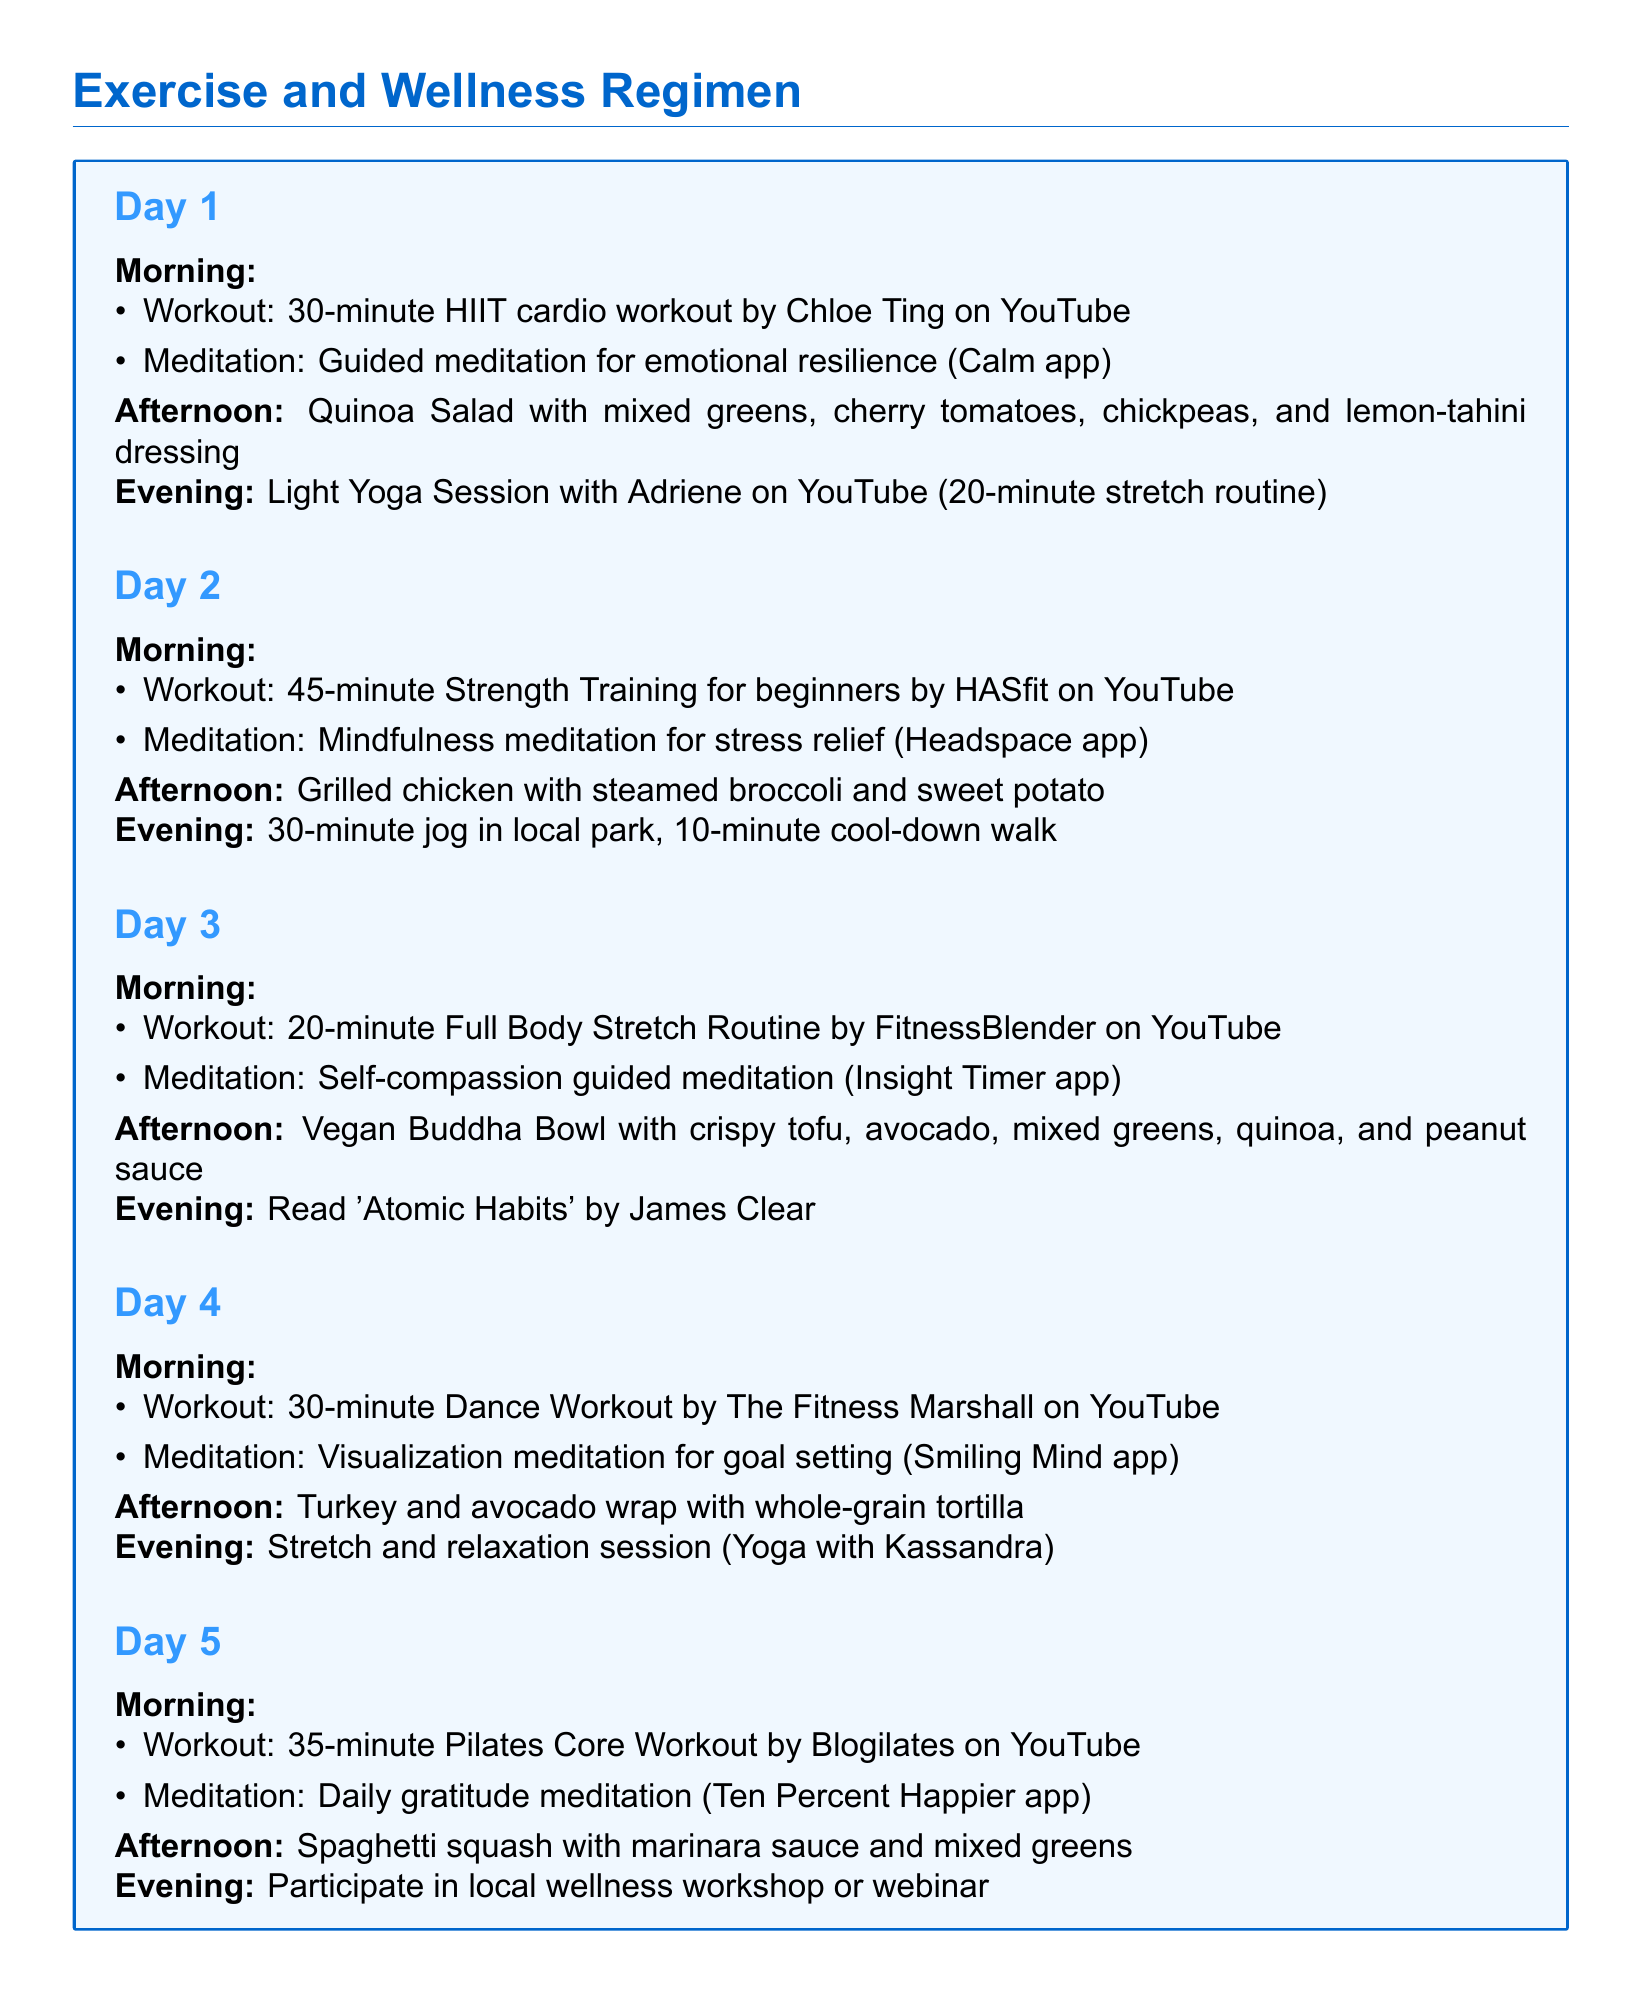what is the duration of the HIIT cardio workout? The HIIT cardio workout including details in the document specifies a duration of 30 minutes.
Answer: 30 minutes which app is used for emotional resilience meditation? The document lists the Calm app for the guided meditation focused on emotional resilience.
Answer: Calm app how many days are included in the exercise regimen? The document outlines a total of five days for the exercise and wellness regimen.
Answer: Five days what is the lunch option on Day 3? The lunch option provided for Day 3 in the document is a Vegan Buddha Bowl.
Answer: Vegan Buddha Bowl what type of workout is scheduled for the morning of Day 4? In the morning of Day 4, the document schedules a 30-minute Dance Workout.
Answer: Dance Workout which meditation app is recommended for stress relief? The recommended app for mindfulness meditation focused on stress relief is the Headspace app.
Answer: Headspace app what meal is planned for the afternoon of Day 5? The afternoon meal specified for Day 5 in the document is spaghetti squash with marinara sauce.
Answer: Spaghetti squash with marinara sauce what is the evening activity on Day 2? The document states that the evening activity on Day 2 consists of a 30-minute jog in the local park.
Answer: 30-minute jog how long is the Pilates Core Workout scheduled for Day 5? The Pilates Core Workout scheduled for Day 5 lasts for 35 minutes according to the document.
Answer: 35 minutes 